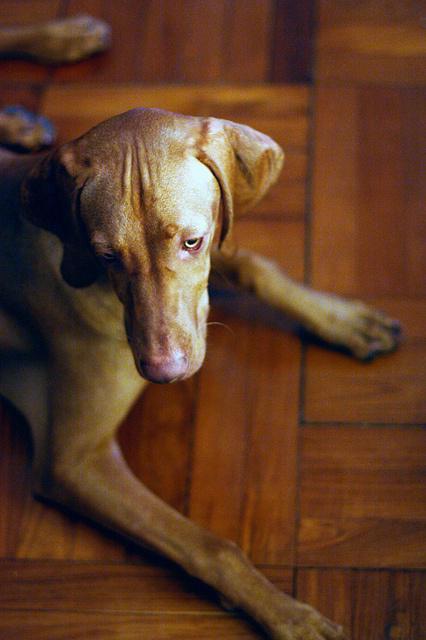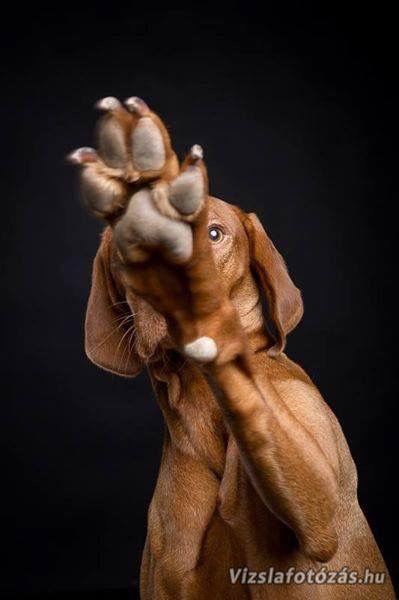The first image is the image on the left, the second image is the image on the right. Examine the images to the left and right. Is the description "The left image shows a fog in a reclining pose, and the dark toes on the underside of a dog's front paw are visible in the image on the right." accurate? Answer yes or no. Yes. The first image is the image on the left, the second image is the image on the right. Evaluate the accuracy of this statement regarding the images: "At least one dog is laying on a pillow.". Is it true? Answer yes or no. No. 